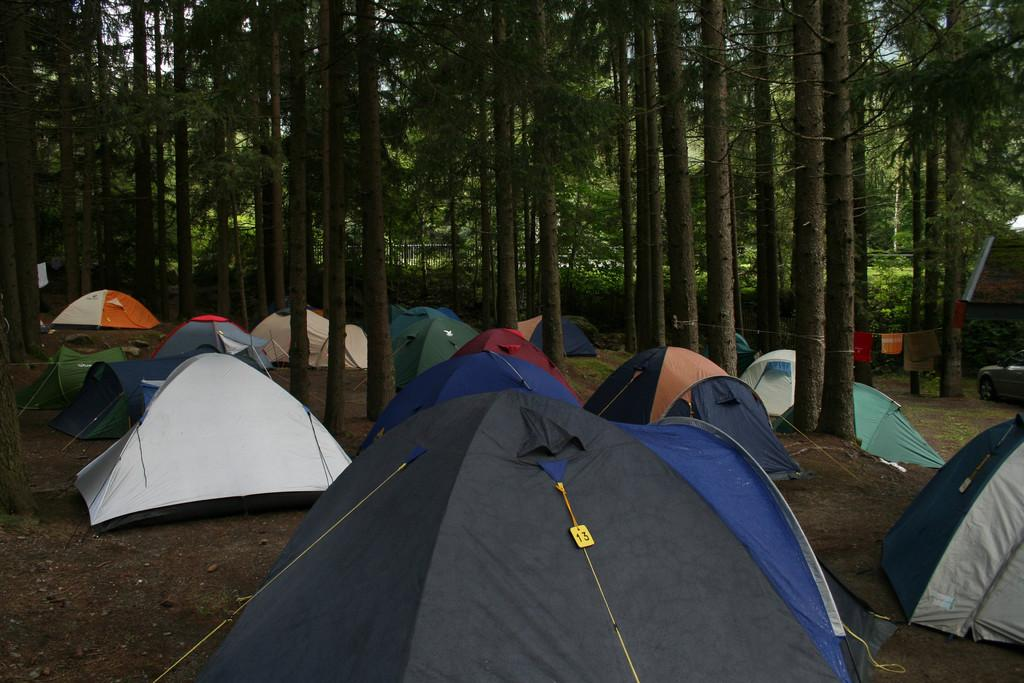What type of temporary shelters can be seen on the ground in the image? There are camping tents on the ground in the image. How can the tents be distinguished from one another? The tents are in different colors. What can be seen in the background of the image? There are trees in the background of the image. What vehicle is visible on the right side of the image? There is a car on the right side of the image. What type of religious ceremony is taking place in the image? There is no indication of a religious ceremony in the image; it features camping tents, trees, and a car. What type of mine can be seen in the image? There is no mine present in the image; it features camping tents, trees, and a car. 